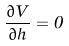Convert formula to latex. <formula><loc_0><loc_0><loc_500><loc_500>\frac { \partial V } { \partial h } = 0</formula> 